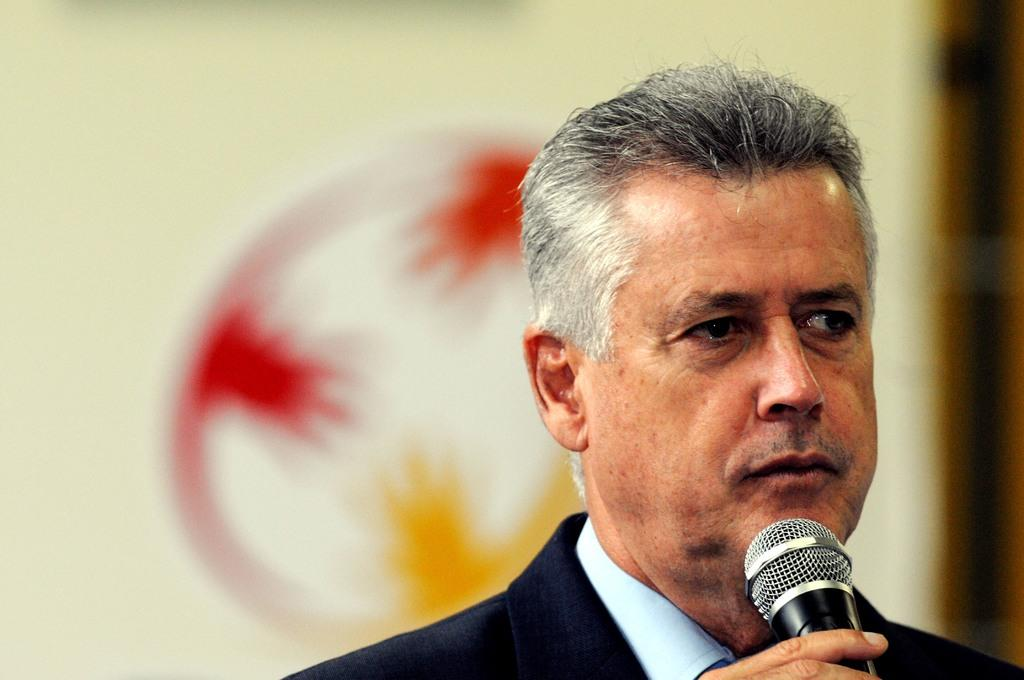What is the main subject of the image? There is a person in the image. What is the person holding in his hand? The person is holding a microphone in his hand. Can you describe the background of the image? The background of the image is blurred. How many pies can be seen on the shelf behind the person in the image? There are no pies visible in the image. Can you tell me where the kitty is hiding in the image? There is no kitty present in the image. What type of books can be seen on the shelves in the image? There are no shelves or books visible in the image. 